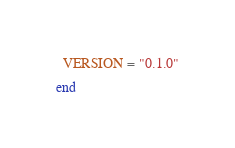<code> <loc_0><loc_0><loc_500><loc_500><_Crystal_>  VERSION = "0.1.0"

end
</code> 